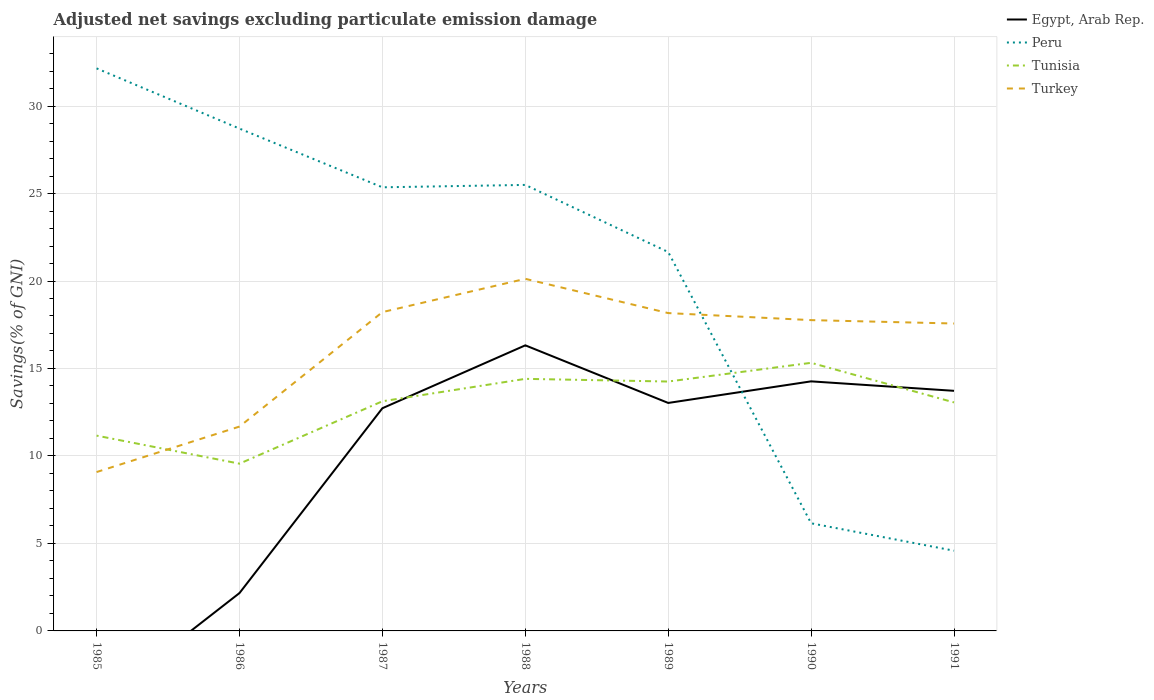Is the number of lines equal to the number of legend labels?
Your response must be concise. No. Across all years, what is the maximum adjusted net savings in Turkey?
Your response must be concise. 9.08. What is the total adjusted net savings in Egypt, Arab Rep. in the graph?
Ensure brevity in your answer.  0.54. What is the difference between the highest and the second highest adjusted net savings in Peru?
Your answer should be very brief. 27.57. What is the difference between two consecutive major ticks on the Y-axis?
Offer a very short reply. 5. Does the graph contain any zero values?
Make the answer very short. Yes. Does the graph contain grids?
Offer a terse response. Yes. How many legend labels are there?
Provide a short and direct response. 4. What is the title of the graph?
Provide a succinct answer. Adjusted net savings excluding particulate emission damage. What is the label or title of the X-axis?
Your response must be concise. Years. What is the label or title of the Y-axis?
Make the answer very short. Savings(% of GNI). What is the Savings(% of GNI) in Egypt, Arab Rep. in 1985?
Give a very brief answer. 0. What is the Savings(% of GNI) in Peru in 1985?
Your answer should be compact. 32.15. What is the Savings(% of GNI) of Tunisia in 1985?
Offer a terse response. 11.16. What is the Savings(% of GNI) of Turkey in 1985?
Offer a terse response. 9.08. What is the Savings(% of GNI) of Egypt, Arab Rep. in 1986?
Offer a terse response. 2.16. What is the Savings(% of GNI) of Peru in 1986?
Your response must be concise. 28.71. What is the Savings(% of GNI) of Tunisia in 1986?
Make the answer very short. 9.56. What is the Savings(% of GNI) of Turkey in 1986?
Keep it short and to the point. 11.68. What is the Savings(% of GNI) of Egypt, Arab Rep. in 1987?
Ensure brevity in your answer.  12.73. What is the Savings(% of GNI) in Peru in 1987?
Keep it short and to the point. 25.36. What is the Savings(% of GNI) of Tunisia in 1987?
Your response must be concise. 13.13. What is the Savings(% of GNI) in Turkey in 1987?
Give a very brief answer. 18.22. What is the Savings(% of GNI) of Egypt, Arab Rep. in 1988?
Ensure brevity in your answer.  16.32. What is the Savings(% of GNI) of Peru in 1988?
Provide a short and direct response. 25.49. What is the Savings(% of GNI) in Tunisia in 1988?
Offer a very short reply. 14.41. What is the Savings(% of GNI) in Turkey in 1988?
Your response must be concise. 20.12. What is the Savings(% of GNI) in Egypt, Arab Rep. in 1989?
Ensure brevity in your answer.  13.03. What is the Savings(% of GNI) in Peru in 1989?
Ensure brevity in your answer.  21.66. What is the Savings(% of GNI) of Tunisia in 1989?
Provide a short and direct response. 14.25. What is the Savings(% of GNI) in Turkey in 1989?
Your answer should be very brief. 18.17. What is the Savings(% of GNI) in Egypt, Arab Rep. in 1990?
Your answer should be compact. 14.26. What is the Savings(% of GNI) of Peru in 1990?
Your answer should be compact. 6.15. What is the Savings(% of GNI) of Tunisia in 1990?
Provide a short and direct response. 15.32. What is the Savings(% of GNI) in Turkey in 1990?
Offer a terse response. 17.76. What is the Savings(% of GNI) in Egypt, Arab Rep. in 1991?
Your response must be concise. 13.72. What is the Savings(% of GNI) of Peru in 1991?
Ensure brevity in your answer.  4.58. What is the Savings(% of GNI) in Tunisia in 1991?
Offer a very short reply. 13.06. What is the Savings(% of GNI) of Turkey in 1991?
Make the answer very short. 17.57. Across all years, what is the maximum Savings(% of GNI) in Egypt, Arab Rep.?
Ensure brevity in your answer.  16.32. Across all years, what is the maximum Savings(% of GNI) in Peru?
Give a very brief answer. 32.15. Across all years, what is the maximum Savings(% of GNI) in Tunisia?
Your answer should be compact. 15.32. Across all years, what is the maximum Savings(% of GNI) of Turkey?
Your response must be concise. 20.12. Across all years, what is the minimum Savings(% of GNI) of Peru?
Your answer should be very brief. 4.58. Across all years, what is the minimum Savings(% of GNI) in Tunisia?
Your answer should be very brief. 9.56. Across all years, what is the minimum Savings(% of GNI) in Turkey?
Your answer should be compact. 9.08. What is the total Savings(% of GNI) of Egypt, Arab Rep. in the graph?
Make the answer very short. 72.23. What is the total Savings(% of GNI) in Peru in the graph?
Give a very brief answer. 144.1. What is the total Savings(% of GNI) of Tunisia in the graph?
Give a very brief answer. 90.89. What is the total Savings(% of GNI) of Turkey in the graph?
Offer a terse response. 112.61. What is the difference between the Savings(% of GNI) of Peru in 1985 and that in 1986?
Offer a terse response. 3.44. What is the difference between the Savings(% of GNI) of Tunisia in 1985 and that in 1986?
Provide a short and direct response. 1.6. What is the difference between the Savings(% of GNI) of Turkey in 1985 and that in 1986?
Provide a short and direct response. -2.6. What is the difference between the Savings(% of GNI) in Peru in 1985 and that in 1987?
Give a very brief answer. 6.8. What is the difference between the Savings(% of GNI) in Tunisia in 1985 and that in 1987?
Your response must be concise. -1.96. What is the difference between the Savings(% of GNI) of Turkey in 1985 and that in 1987?
Your response must be concise. -9.14. What is the difference between the Savings(% of GNI) in Peru in 1985 and that in 1988?
Your answer should be very brief. 6.66. What is the difference between the Savings(% of GNI) of Tunisia in 1985 and that in 1988?
Keep it short and to the point. -3.25. What is the difference between the Savings(% of GNI) of Turkey in 1985 and that in 1988?
Your answer should be compact. -11.04. What is the difference between the Savings(% of GNI) of Peru in 1985 and that in 1989?
Your response must be concise. 10.5. What is the difference between the Savings(% of GNI) in Tunisia in 1985 and that in 1989?
Ensure brevity in your answer.  -3.09. What is the difference between the Savings(% of GNI) of Turkey in 1985 and that in 1989?
Ensure brevity in your answer.  -9.09. What is the difference between the Savings(% of GNI) of Peru in 1985 and that in 1990?
Your answer should be compact. 26. What is the difference between the Savings(% of GNI) of Tunisia in 1985 and that in 1990?
Keep it short and to the point. -4.16. What is the difference between the Savings(% of GNI) of Turkey in 1985 and that in 1990?
Keep it short and to the point. -8.68. What is the difference between the Savings(% of GNI) in Peru in 1985 and that in 1991?
Offer a very short reply. 27.57. What is the difference between the Savings(% of GNI) of Tunisia in 1985 and that in 1991?
Offer a very short reply. -1.9. What is the difference between the Savings(% of GNI) of Turkey in 1985 and that in 1991?
Provide a succinct answer. -8.49. What is the difference between the Savings(% of GNI) in Egypt, Arab Rep. in 1986 and that in 1987?
Give a very brief answer. -10.56. What is the difference between the Savings(% of GNI) in Peru in 1986 and that in 1987?
Make the answer very short. 3.36. What is the difference between the Savings(% of GNI) in Tunisia in 1986 and that in 1987?
Give a very brief answer. -3.57. What is the difference between the Savings(% of GNI) in Turkey in 1986 and that in 1987?
Make the answer very short. -6.54. What is the difference between the Savings(% of GNI) in Egypt, Arab Rep. in 1986 and that in 1988?
Your answer should be compact. -14.16. What is the difference between the Savings(% of GNI) in Peru in 1986 and that in 1988?
Your answer should be compact. 3.22. What is the difference between the Savings(% of GNI) in Tunisia in 1986 and that in 1988?
Your answer should be compact. -4.85. What is the difference between the Savings(% of GNI) in Turkey in 1986 and that in 1988?
Offer a terse response. -8.44. What is the difference between the Savings(% of GNI) in Egypt, Arab Rep. in 1986 and that in 1989?
Give a very brief answer. -10.87. What is the difference between the Savings(% of GNI) of Peru in 1986 and that in 1989?
Offer a very short reply. 7.05. What is the difference between the Savings(% of GNI) of Tunisia in 1986 and that in 1989?
Ensure brevity in your answer.  -4.69. What is the difference between the Savings(% of GNI) in Turkey in 1986 and that in 1989?
Keep it short and to the point. -6.49. What is the difference between the Savings(% of GNI) in Egypt, Arab Rep. in 1986 and that in 1990?
Provide a short and direct response. -12.1. What is the difference between the Savings(% of GNI) of Peru in 1986 and that in 1990?
Your answer should be compact. 22.56. What is the difference between the Savings(% of GNI) in Tunisia in 1986 and that in 1990?
Provide a short and direct response. -5.76. What is the difference between the Savings(% of GNI) in Turkey in 1986 and that in 1990?
Offer a terse response. -6.08. What is the difference between the Savings(% of GNI) in Egypt, Arab Rep. in 1986 and that in 1991?
Your answer should be compact. -11.56. What is the difference between the Savings(% of GNI) in Peru in 1986 and that in 1991?
Provide a short and direct response. 24.13. What is the difference between the Savings(% of GNI) of Tunisia in 1986 and that in 1991?
Offer a very short reply. -3.5. What is the difference between the Savings(% of GNI) in Turkey in 1986 and that in 1991?
Provide a short and direct response. -5.89. What is the difference between the Savings(% of GNI) of Egypt, Arab Rep. in 1987 and that in 1988?
Provide a short and direct response. -3.59. What is the difference between the Savings(% of GNI) of Peru in 1987 and that in 1988?
Offer a very short reply. -0.14. What is the difference between the Savings(% of GNI) of Tunisia in 1987 and that in 1988?
Offer a very short reply. -1.28. What is the difference between the Savings(% of GNI) in Turkey in 1987 and that in 1988?
Make the answer very short. -1.9. What is the difference between the Savings(% of GNI) in Egypt, Arab Rep. in 1987 and that in 1989?
Give a very brief answer. -0.3. What is the difference between the Savings(% of GNI) in Peru in 1987 and that in 1989?
Provide a succinct answer. 3.7. What is the difference between the Savings(% of GNI) of Tunisia in 1987 and that in 1989?
Your response must be concise. -1.13. What is the difference between the Savings(% of GNI) of Turkey in 1987 and that in 1989?
Offer a very short reply. 0.06. What is the difference between the Savings(% of GNI) of Egypt, Arab Rep. in 1987 and that in 1990?
Your answer should be compact. -1.54. What is the difference between the Savings(% of GNI) in Peru in 1987 and that in 1990?
Ensure brevity in your answer.  19.2. What is the difference between the Savings(% of GNI) in Tunisia in 1987 and that in 1990?
Give a very brief answer. -2.2. What is the difference between the Savings(% of GNI) in Turkey in 1987 and that in 1990?
Your answer should be very brief. 0.46. What is the difference between the Savings(% of GNI) of Egypt, Arab Rep. in 1987 and that in 1991?
Make the answer very short. -0.99. What is the difference between the Savings(% of GNI) in Peru in 1987 and that in 1991?
Give a very brief answer. 20.77. What is the difference between the Savings(% of GNI) of Tunisia in 1987 and that in 1991?
Provide a succinct answer. 0.07. What is the difference between the Savings(% of GNI) in Turkey in 1987 and that in 1991?
Keep it short and to the point. 0.65. What is the difference between the Savings(% of GNI) in Egypt, Arab Rep. in 1988 and that in 1989?
Ensure brevity in your answer.  3.29. What is the difference between the Savings(% of GNI) of Peru in 1988 and that in 1989?
Give a very brief answer. 3.84. What is the difference between the Savings(% of GNI) in Tunisia in 1988 and that in 1989?
Keep it short and to the point. 0.15. What is the difference between the Savings(% of GNI) of Turkey in 1988 and that in 1989?
Your answer should be compact. 1.96. What is the difference between the Savings(% of GNI) in Egypt, Arab Rep. in 1988 and that in 1990?
Offer a terse response. 2.06. What is the difference between the Savings(% of GNI) of Peru in 1988 and that in 1990?
Keep it short and to the point. 19.34. What is the difference between the Savings(% of GNI) of Tunisia in 1988 and that in 1990?
Your response must be concise. -0.92. What is the difference between the Savings(% of GNI) of Turkey in 1988 and that in 1990?
Your response must be concise. 2.36. What is the difference between the Savings(% of GNI) in Egypt, Arab Rep. in 1988 and that in 1991?
Offer a terse response. 2.6. What is the difference between the Savings(% of GNI) of Peru in 1988 and that in 1991?
Provide a short and direct response. 20.91. What is the difference between the Savings(% of GNI) in Tunisia in 1988 and that in 1991?
Keep it short and to the point. 1.35. What is the difference between the Savings(% of GNI) in Turkey in 1988 and that in 1991?
Give a very brief answer. 2.55. What is the difference between the Savings(% of GNI) of Egypt, Arab Rep. in 1989 and that in 1990?
Your response must be concise. -1.23. What is the difference between the Savings(% of GNI) in Peru in 1989 and that in 1990?
Give a very brief answer. 15.5. What is the difference between the Savings(% of GNI) in Tunisia in 1989 and that in 1990?
Offer a terse response. -1.07. What is the difference between the Savings(% of GNI) in Turkey in 1989 and that in 1990?
Make the answer very short. 0.4. What is the difference between the Savings(% of GNI) of Egypt, Arab Rep. in 1989 and that in 1991?
Ensure brevity in your answer.  -0.69. What is the difference between the Savings(% of GNI) in Peru in 1989 and that in 1991?
Your response must be concise. 17.07. What is the difference between the Savings(% of GNI) of Tunisia in 1989 and that in 1991?
Your answer should be very brief. 1.19. What is the difference between the Savings(% of GNI) in Turkey in 1989 and that in 1991?
Offer a very short reply. 0.6. What is the difference between the Savings(% of GNI) of Egypt, Arab Rep. in 1990 and that in 1991?
Make the answer very short. 0.54. What is the difference between the Savings(% of GNI) in Peru in 1990 and that in 1991?
Provide a succinct answer. 1.57. What is the difference between the Savings(% of GNI) in Tunisia in 1990 and that in 1991?
Offer a very short reply. 2.26. What is the difference between the Savings(% of GNI) in Turkey in 1990 and that in 1991?
Make the answer very short. 0.19. What is the difference between the Savings(% of GNI) in Peru in 1985 and the Savings(% of GNI) in Tunisia in 1986?
Offer a very short reply. 22.59. What is the difference between the Savings(% of GNI) of Peru in 1985 and the Savings(% of GNI) of Turkey in 1986?
Your answer should be very brief. 20.47. What is the difference between the Savings(% of GNI) in Tunisia in 1985 and the Savings(% of GNI) in Turkey in 1986?
Offer a very short reply. -0.52. What is the difference between the Savings(% of GNI) of Peru in 1985 and the Savings(% of GNI) of Tunisia in 1987?
Offer a very short reply. 19.03. What is the difference between the Savings(% of GNI) of Peru in 1985 and the Savings(% of GNI) of Turkey in 1987?
Your response must be concise. 13.93. What is the difference between the Savings(% of GNI) of Tunisia in 1985 and the Savings(% of GNI) of Turkey in 1987?
Provide a succinct answer. -7.06. What is the difference between the Savings(% of GNI) of Peru in 1985 and the Savings(% of GNI) of Tunisia in 1988?
Ensure brevity in your answer.  17.75. What is the difference between the Savings(% of GNI) of Peru in 1985 and the Savings(% of GNI) of Turkey in 1988?
Offer a terse response. 12.03. What is the difference between the Savings(% of GNI) of Tunisia in 1985 and the Savings(% of GNI) of Turkey in 1988?
Make the answer very short. -8.96. What is the difference between the Savings(% of GNI) of Peru in 1985 and the Savings(% of GNI) of Tunisia in 1989?
Give a very brief answer. 17.9. What is the difference between the Savings(% of GNI) in Peru in 1985 and the Savings(% of GNI) in Turkey in 1989?
Keep it short and to the point. 13.99. What is the difference between the Savings(% of GNI) of Tunisia in 1985 and the Savings(% of GNI) of Turkey in 1989?
Keep it short and to the point. -7. What is the difference between the Savings(% of GNI) of Peru in 1985 and the Savings(% of GNI) of Tunisia in 1990?
Make the answer very short. 16.83. What is the difference between the Savings(% of GNI) of Peru in 1985 and the Savings(% of GNI) of Turkey in 1990?
Keep it short and to the point. 14.39. What is the difference between the Savings(% of GNI) in Tunisia in 1985 and the Savings(% of GNI) in Turkey in 1990?
Give a very brief answer. -6.6. What is the difference between the Savings(% of GNI) in Peru in 1985 and the Savings(% of GNI) in Tunisia in 1991?
Your answer should be compact. 19.09. What is the difference between the Savings(% of GNI) of Peru in 1985 and the Savings(% of GNI) of Turkey in 1991?
Give a very brief answer. 14.58. What is the difference between the Savings(% of GNI) in Tunisia in 1985 and the Savings(% of GNI) in Turkey in 1991?
Ensure brevity in your answer.  -6.41. What is the difference between the Savings(% of GNI) in Egypt, Arab Rep. in 1986 and the Savings(% of GNI) in Peru in 1987?
Your answer should be compact. -23.19. What is the difference between the Savings(% of GNI) of Egypt, Arab Rep. in 1986 and the Savings(% of GNI) of Tunisia in 1987?
Provide a short and direct response. -10.96. What is the difference between the Savings(% of GNI) of Egypt, Arab Rep. in 1986 and the Savings(% of GNI) of Turkey in 1987?
Keep it short and to the point. -16.06. What is the difference between the Savings(% of GNI) in Peru in 1986 and the Savings(% of GNI) in Tunisia in 1987?
Keep it short and to the point. 15.58. What is the difference between the Savings(% of GNI) in Peru in 1986 and the Savings(% of GNI) in Turkey in 1987?
Your answer should be compact. 10.49. What is the difference between the Savings(% of GNI) of Tunisia in 1986 and the Savings(% of GNI) of Turkey in 1987?
Your answer should be very brief. -8.66. What is the difference between the Savings(% of GNI) in Egypt, Arab Rep. in 1986 and the Savings(% of GNI) in Peru in 1988?
Your response must be concise. -23.33. What is the difference between the Savings(% of GNI) in Egypt, Arab Rep. in 1986 and the Savings(% of GNI) in Tunisia in 1988?
Ensure brevity in your answer.  -12.24. What is the difference between the Savings(% of GNI) of Egypt, Arab Rep. in 1986 and the Savings(% of GNI) of Turkey in 1988?
Make the answer very short. -17.96. What is the difference between the Savings(% of GNI) of Peru in 1986 and the Savings(% of GNI) of Tunisia in 1988?
Provide a short and direct response. 14.3. What is the difference between the Savings(% of GNI) in Peru in 1986 and the Savings(% of GNI) in Turkey in 1988?
Give a very brief answer. 8.59. What is the difference between the Savings(% of GNI) in Tunisia in 1986 and the Savings(% of GNI) in Turkey in 1988?
Make the answer very short. -10.56. What is the difference between the Savings(% of GNI) of Egypt, Arab Rep. in 1986 and the Savings(% of GNI) of Peru in 1989?
Provide a succinct answer. -19.49. What is the difference between the Savings(% of GNI) of Egypt, Arab Rep. in 1986 and the Savings(% of GNI) of Tunisia in 1989?
Your response must be concise. -12.09. What is the difference between the Savings(% of GNI) of Egypt, Arab Rep. in 1986 and the Savings(% of GNI) of Turkey in 1989?
Your answer should be compact. -16. What is the difference between the Savings(% of GNI) in Peru in 1986 and the Savings(% of GNI) in Tunisia in 1989?
Provide a succinct answer. 14.46. What is the difference between the Savings(% of GNI) of Peru in 1986 and the Savings(% of GNI) of Turkey in 1989?
Your answer should be compact. 10.54. What is the difference between the Savings(% of GNI) in Tunisia in 1986 and the Savings(% of GNI) in Turkey in 1989?
Offer a very short reply. -8.61. What is the difference between the Savings(% of GNI) in Egypt, Arab Rep. in 1986 and the Savings(% of GNI) in Peru in 1990?
Your response must be concise. -3.99. What is the difference between the Savings(% of GNI) in Egypt, Arab Rep. in 1986 and the Savings(% of GNI) in Tunisia in 1990?
Provide a succinct answer. -13.16. What is the difference between the Savings(% of GNI) of Egypt, Arab Rep. in 1986 and the Savings(% of GNI) of Turkey in 1990?
Offer a very short reply. -15.6. What is the difference between the Savings(% of GNI) of Peru in 1986 and the Savings(% of GNI) of Tunisia in 1990?
Provide a succinct answer. 13.39. What is the difference between the Savings(% of GNI) in Peru in 1986 and the Savings(% of GNI) in Turkey in 1990?
Your response must be concise. 10.95. What is the difference between the Savings(% of GNI) in Tunisia in 1986 and the Savings(% of GNI) in Turkey in 1990?
Offer a very short reply. -8.2. What is the difference between the Savings(% of GNI) in Egypt, Arab Rep. in 1986 and the Savings(% of GNI) in Peru in 1991?
Your answer should be very brief. -2.42. What is the difference between the Savings(% of GNI) in Egypt, Arab Rep. in 1986 and the Savings(% of GNI) in Tunisia in 1991?
Your response must be concise. -10.9. What is the difference between the Savings(% of GNI) of Egypt, Arab Rep. in 1986 and the Savings(% of GNI) of Turkey in 1991?
Provide a short and direct response. -15.41. What is the difference between the Savings(% of GNI) of Peru in 1986 and the Savings(% of GNI) of Tunisia in 1991?
Give a very brief answer. 15.65. What is the difference between the Savings(% of GNI) of Peru in 1986 and the Savings(% of GNI) of Turkey in 1991?
Give a very brief answer. 11.14. What is the difference between the Savings(% of GNI) in Tunisia in 1986 and the Savings(% of GNI) in Turkey in 1991?
Ensure brevity in your answer.  -8.01. What is the difference between the Savings(% of GNI) in Egypt, Arab Rep. in 1987 and the Savings(% of GNI) in Peru in 1988?
Your response must be concise. -12.76. What is the difference between the Savings(% of GNI) of Egypt, Arab Rep. in 1987 and the Savings(% of GNI) of Tunisia in 1988?
Your answer should be very brief. -1.68. What is the difference between the Savings(% of GNI) of Egypt, Arab Rep. in 1987 and the Savings(% of GNI) of Turkey in 1988?
Offer a terse response. -7.4. What is the difference between the Savings(% of GNI) in Peru in 1987 and the Savings(% of GNI) in Tunisia in 1988?
Provide a short and direct response. 10.95. What is the difference between the Savings(% of GNI) in Peru in 1987 and the Savings(% of GNI) in Turkey in 1988?
Your response must be concise. 5.23. What is the difference between the Savings(% of GNI) of Tunisia in 1987 and the Savings(% of GNI) of Turkey in 1988?
Offer a very short reply. -7. What is the difference between the Savings(% of GNI) of Egypt, Arab Rep. in 1987 and the Savings(% of GNI) of Peru in 1989?
Your answer should be very brief. -8.93. What is the difference between the Savings(% of GNI) of Egypt, Arab Rep. in 1987 and the Savings(% of GNI) of Tunisia in 1989?
Make the answer very short. -1.53. What is the difference between the Savings(% of GNI) in Egypt, Arab Rep. in 1987 and the Savings(% of GNI) in Turkey in 1989?
Make the answer very short. -5.44. What is the difference between the Savings(% of GNI) of Peru in 1987 and the Savings(% of GNI) of Tunisia in 1989?
Provide a succinct answer. 11.1. What is the difference between the Savings(% of GNI) in Peru in 1987 and the Savings(% of GNI) in Turkey in 1989?
Your answer should be very brief. 7.19. What is the difference between the Savings(% of GNI) of Tunisia in 1987 and the Savings(% of GNI) of Turkey in 1989?
Offer a terse response. -5.04. What is the difference between the Savings(% of GNI) in Egypt, Arab Rep. in 1987 and the Savings(% of GNI) in Peru in 1990?
Your answer should be compact. 6.58. What is the difference between the Savings(% of GNI) in Egypt, Arab Rep. in 1987 and the Savings(% of GNI) in Tunisia in 1990?
Offer a terse response. -2.6. What is the difference between the Savings(% of GNI) in Egypt, Arab Rep. in 1987 and the Savings(% of GNI) in Turkey in 1990?
Keep it short and to the point. -5.04. What is the difference between the Savings(% of GNI) in Peru in 1987 and the Savings(% of GNI) in Tunisia in 1990?
Keep it short and to the point. 10.03. What is the difference between the Savings(% of GNI) in Peru in 1987 and the Savings(% of GNI) in Turkey in 1990?
Provide a succinct answer. 7.59. What is the difference between the Savings(% of GNI) in Tunisia in 1987 and the Savings(% of GNI) in Turkey in 1990?
Provide a short and direct response. -4.64. What is the difference between the Savings(% of GNI) in Egypt, Arab Rep. in 1987 and the Savings(% of GNI) in Peru in 1991?
Your answer should be compact. 8.14. What is the difference between the Savings(% of GNI) in Egypt, Arab Rep. in 1987 and the Savings(% of GNI) in Tunisia in 1991?
Provide a short and direct response. -0.33. What is the difference between the Savings(% of GNI) of Egypt, Arab Rep. in 1987 and the Savings(% of GNI) of Turkey in 1991?
Your response must be concise. -4.84. What is the difference between the Savings(% of GNI) of Peru in 1987 and the Savings(% of GNI) of Tunisia in 1991?
Give a very brief answer. 12.29. What is the difference between the Savings(% of GNI) of Peru in 1987 and the Savings(% of GNI) of Turkey in 1991?
Your response must be concise. 7.79. What is the difference between the Savings(% of GNI) of Tunisia in 1987 and the Savings(% of GNI) of Turkey in 1991?
Your answer should be very brief. -4.44. What is the difference between the Savings(% of GNI) of Egypt, Arab Rep. in 1988 and the Savings(% of GNI) of Peru in 1989?
Offer a very short reply. -5.33. What is the difference between the Savings(% of GNI) of Egypt, Arab Rep. in 1988 and the Savings(% of GNI) of Tunisia in 1989?
Offer a very short reply. 2.07. What is the difference between the Savings(% of GNI) in Egypt, Arab Rep. in 1988 and the Savings(% of GNI) in Turkey in 1989?
Make the answer very short. -1.84. What is the difference between the Savings(% of GNI) of Peru in 1988 and the Savings(% of GNI) of Tunisia in 1989?
Provide a succinct answer. 11.24. What is the difference between the Savings(% of GNI) of Peru in 1988 and the Savings(% of GNI) of Turkey in 1989?
Give a very brief answer. 7.33. What is the difference between the Savings(% of GNI) in Tunisia in 1988 and the Savings(% of GNI) in Turkey in 1989?
Provide a short and direct response. -3.76. What is the difference between the Savings(% of GNI) in Egypt, Arab Rep. in 1988 and the Savings(% of GNI) in Peru in 1990?
Give a very brief answer. 10.17. What is the difference between the Savings(% of GNI) of Egypt, Arab Rep. in 1988 and the Savings(% of GNI) of Turkey in 1990?
Give a very brief answer. -1.44. What is the difference between the Savings(% of GNI) of Peru in 1988 and the Savings(% of GNI) of Tunisia in 1990?
Provide a short and direct response. 10.17. What is the difference between the Savings(% of GNI) of Peru in 1988 and the Savings(% of GNI) of Turkey in 1990?
Your answer should be compact. 7.73. What is the difference between the Savings(% of GNI) of Tunisia in 1988 and the Savings(% of GNI) of Turkey in 1990?
Offer a terse response. -3.36. What is the difference between the Savings(% of GNI) in Egypt, Arab Rep. in 1988 and the Savings(% of GNI) in Peru in 1991?
Give a very brief answer. 11.74. What is the difference between the Savings(% of GNI) of Egypt, Arab Rep. in 1988 and the Savings(% of GNI) of Tunisia in 1991?
Provide a succinct answer. 3.26. What is the difference between the Savings(% of GNI) in Egypt, Arab Rep. in 1988 and the Savings(% of GNI) in Turkey in 1991?
Give a very brief answer. -1.25. What is the difference between the Savings(% of GNI) of Peru in 1988 and the Savings(% of GNI) of Tunisia in 1991?
Your response must be concise. 12.43. What is the difference between the Savings(% of GNI) in Peru in 1988 and the Savings(% of GNI) in Turkey in 1991?
Your answer should be very brief. 7.92. What is the difference between the Savings(% of GNI) in Tunisia in 1988 and the Savings(% of GNI) in Turkey in 1991?
Offer a very short reply. -3.16. What is the difference between the Savings(% of GNI) of Egypt, Arab Rep. in 1989 and the Savings(% of GNI) of Peru in 1990?
Your answer should be compact. 6.88. What is the difference between the Savings(% of GNI) in Egypt, Arab Rep. in 1989 and the Savings(% of GNI) in Tunisia in 1990?
Your response must be concise. -2.29. What is the difference between the Savings(% of GNI) of Egypt, Arab Rep. in 1989 and the Savings(% of GNI) of Turkey in 1990?
Ensure brevity in your answer.  -4.73. What is the difference between the Savings(% of GNI) of Peru in 1989 and the Savings(% of GNI) of Tunisia in 1990?
Ensure brevity in your answer.  6.33. What is the difference between the Savings(% of GNI) in Peru in 1989 and the Savings(% of GNI) in Turkey in 1990?
Give a very brief answer. 3.89. What is the difference between the Savings(% of GNI) in Tunisia in 1989 and the Savings(% of GNI) in Turkey in 1990?
Offer a very short reply. -3.51. What is the difference between the Savings(% of GNI) in Egypt, Arab Rep. in 1989 and the Savings(% of GNI) in Peru in 1991?
Provide a succinct answer. 8.45. What is the difference between the Savings(% of GNI) in Egypt, Arab Rep. in 1989 and the Savings(% of GNI) in Tunisia in 1991?
Offer a very short reply. -0.03. What is the difference between the Savings(% of GNI) in Egypt, Arab Rep. in 1989 and the Savings(% of GNI) in Turkey in 1991?
Keep it short and to the point. -4.54. What is the difference between the Savings(% of GNI) of Peru in 1989 and the Savings(% of GNI) of Tunisia in 1991?
Your response must be concise. 8.59. What is the difference between the Savings(% of GNI) in Peru in 1989 and the Savings(% of GNI) in Turkey in 1991?
Make the answer very short. 4.09. What is the difference between the Savings(% of GNI) in Tunisia in 1989 and the Savings(% of GNI) in Turkey in 1991?
Offer a terse response. -3.32. What is the difference between the Savings(% of GNI) in Egypt, Arab Rep. in 1990 and the Savings(% of GNI) in Peru in 1991?
Provide a succinct answer. 9.68. What is the difference between the Savings(% of GNI) in Egypt, Arab Rep. in 1990 and the Savings(% of GNI) in Tunisia in 1991?
Your answer should be compact. 1.2. What is the difference between the Savings(% of GNI) in Egypt, Arab Rep. in 1990 and the Savings(% of GNI) in Turkey in 1991?
Offer a terse response. -3.31. What is the difference between the Savings(% of GNI) in Peru in 1990 and the Savings(% of GNI) in Tunisia in 1991?
Your answer should be compact. -6.91. What is the difference between the Savings(% of GNI) of Peru in 1990 and the Savings(% of GNI) of Turkey in 1991?
Your response must be concise. -11.42. What is the difference between the Savings(% of GNI) in Tunisia in 1990 and the Savings(% of GNI) in Turkey in 1991?
Your response must be concise. -2.25. What is the average Savings(% of GNI) of Egypt, Arab Rep. per year?
Your response must be concise. 10.32. What is the average Savings(% of GNI) in Peru per year?
Provide a succinct answer. 20.59. What is the average Savings(% of GNI) in Tunisia per year?
Your answer should be compact. 12.98. What is the average Savings(% of GNI) in Turkey per year?
Your response must be concise. 16.09. In the year 1985, what is the difference between the Savings(% of GNI) of Peru and Savings(% of GNI) of Tunisia?
Your response must be concise. 20.99. In the year 1985, what is the difference between the Savings(% of GNI) of Peru and Savings(% of GNI) of Turkey?
Your answer should be compact. 23.07. In the year 1985, what is the difference between the Savings(% of GNI) of Tunisia and Savings(% of GNI) of Turkey?
Provide a short and direct response. 2.08. In the year 1986, what is the difference between the Savings(% of GNI) of Egypt, Arab Rep. and Savings(% of GNI) of Peru?
Make the answer very short. -26.55. In the year 1986, what is the difference between the Savings(% of GNI) of Egypt, Arab Rep. and Savings(% of GNI) of Tunisia?
Ensure brevity in your answer.  -7.4. In the year 1986, what is the difference between the Savings(% of GNI) of Egypt, Arab Rep. and Savings(% of GNI) of Turkey?
Your answer should be compact. -9.52. In the year 1986, what is the difference between the Savings(% of GNI) of Peru and Savings(% of GNI) of Tunisia?
Make the answer very short. 19.15. In the year 1986, what is the difference between the Savings(% of GNI) of Peru and Savings(% of GNI) of Turkey?
Your answer should be compact. 17.03. In the year 1986, what is the difference between the Savings(% of GNI) of Tunisia and Savings(% of GNI) of Turkey?
Offer a terse response. -2.12. In the year 1987, what is the difference between the Savings(% of GNI) in Egypt, Arab Rep. and Savings(% of GNI) in Peru?
Offer a very short reply. -12.63. In the year 1987, what is the difference between the Savings(% of GNI) in Egypt, Arab Rep. and Savings(% of GNI) in Tunisia?
Offer a very short reply. -0.4. In the year 1987, what is the difference between the Savings(% of GNI) in Egypt, Arab Rep. and Savings(% of GNI) in Turkey?
Provide a short and direct response. -5.49. In the year 1987, what is the difference between the Savings(% of GNI) in Peru and Savings(% of GNI) in Tunisia?
Your response must be concise. 12.23. In the year 1987, what is the difference between the Savings(% of GNI) in Peru and Savings(% of GNI) in Turkey?
Offer a very short reply. 7.13. In the year 1987, what is the difference between the Savings(% of GNI) of Tunisia and Savings(% of GNI) of Turkey?
Offer a very short reply. -5.1. In the year 1988, what is the difference between the Savings(% of GNI) of Egypt, Arab Rep. and Savings(% of GNI) of Peru?
Your answer should be compact. -9.17. In the year 1988, what is the difference between the Savings(% of GNI) in Egypt, Arab Rep. and Savings(% of GNI) in Tunisia?
Your answer should be very brief. 1.92. In the year 1988, what is the difference between the Savings(% of GNI) of Egypt, Arab Rep. and Savings(% of GNI) of Turkey?
Give a very brief answer. -3.8. In the year 1988, what is the difference between the Savings(% of GNI) in Peru and Savings(% of GNI) in Tunisia?
Keep it short and to the point. 11.08. In the year 1988, what is the difference between the Savings(% of GNI) in Peru and Savings(% of GNI) in Turkey?
Your response must be concise. 5.37. In the year 1988, what is the difference between the Savings(% of GNI) of Tunisia and Savings(% of GNI) of Turkey?
Your answer should be very brief. -5.72. In the year 1989, what is the difference between the Savings(% of GNI) of Egypt, Arab Rep. and Savings(% of GNI) of Peru?
Your response must be concise. -8.63. In the year 1989, what is the difference between the Savings(% of GNI) in Egypt, Arab Rep. and Savings(% of GNI) in Tunisia?
Ensure brevity in your answer.  -1.22. In the year 1989, what is the difference between the Savings(% of GNI) in Egypt, Arab Rep. and Savings(% of GNI) in Turkey?
Offer a very short reply. -5.14. In the year 1989, what is the difference between the Savings(% of GNI) of Peru and Savings(% of GNI) of Tunisia?
Keep it short and to the point. 7.4. In the year 1989, what is the difference between the Savings(% of GNI) of Peru and Savings(% of GNI) of Turkey?
Provide a succinct answer. 3.49. In the year 1989, what is the difference between the Savings(% of GNI) of Tunisia and Savings(% of GNI) of Turkey?
Ensure brevity in your answer.  -3.91. In the year 1990, what is the difference between the Savings(% of GNI) of Egypt, Arab Rep. and Savings(% of GNI) of Peru?
Keep it short and to the point. 8.11. In the year 1990, what is the difference between the Savings(% of GNI) in Egypt, Arab Rep. and Savings(% of GNI) in Tunisia?
Ensure brevity in your answer.  -1.06. In the year 1990, what is the difference between the Savings(% of GNI) of Egypt, Arab Rep. and Savings(% of GNI) of Turkey?
Your answer should be very brief. -3.5. In the year 1990, what is the difference between the Savings(% of GNI) in Peru and Savings(% of GNI) in Tunisia?
Keep it short and to the point. -9.17. In the year 1990, what is the difference between the Savings(% of GNI) of Peru and Savings(% of GNI) of Turkey?
Provide a short and direct response. -11.61. In the year 1990, what is the difference between the Savings(% of GNI) in Tunisia and Savings(% of GNI) in Turkey?
Make the answer very short. -2.44. In the year 1991, what is the difference between the Savings(% of GNI) in Egypt, Arab Rep. and Savings(% of GNI) in Peru?
Ensure brevity in your answer.  9.14. In the year 1991, what is the difference between the Savings(% of GNI) of Egypt, Arab Rep. and Savings(% of GNI) of Tunisia?
Keep it short and to the point. 0.66. In the year 1991, what is the difference between the Savings(% of GNI) in Egypt, Arab Rep. and Savings(% of GNI) in Turkey?
Make the answer very short. -3.85. In the year 1991, what is the difference between the Savings(% of GNI) of Peru and Savings(% of GNI) of Tunisia?
Provide a short and direct response. -8.48. In the year 1991, what is the difference between the Savings(% of GNI) in Peru and Savings(% of GNI) in Turkey?
Provide a short and direct response. -12.99. In the year 1991, what is the difference between the Savings(% of GNI) in Tunisia and Savings(% of GNI) in Turkey?
Ensure brevity in your answer.  -4.51. What is the ratio of the Savings(% of GNI) of Peru in 1985 to that in 1986?
Offer a terse response. 1.12. What is the ratio of the Savings(% of GNI) of Tunisia in 1985 to that in 1986?
Keep it short and to the point. 1.17. What is the ratio of the Savings(% of GNI) of Turkey in 1985 to that in 1986?
Offer a very short reply. 0.78. What is the ratio of the Savings(% of GNI) in Peru in 1985 to that in 1987?
Give a very brief answer. 1.27. What is the ratio of the Savings(% of GNI) of Tunisia in 1985 to that in 1987?
Offer a very short reply. 0.85. What is the ratio of the Savings(% of GNI) in Turkey in 1985 to that in 1987?
Your answer should be very brief. 0.5. What is the ratio of the Savings(% of GNI) of Peru in 1985 to that in 1988?
Offer a terse response. 1.26. What is the ratio of the Savings(% of GNI) of Tunisia in 1985 to that in 1988?
Provide a succinct answer. 0.77. What is the ratio of the Savings(% of GNI) of Turkey in 1985 to that in 1988?
Keep it short and to the point. 0.45. What is the ratio of the Savings(% of GNI) in Peru in 1985 to that in 1989?
Provide a short and direct response. 1.48. What is the ratio of the Savings(% of GNI) in Tunisia in 1985 to that in 1989?
Keep it short and to the point. 0.78. What is the ratio of the Savings(% of GNI) in Turkey in 1985 to that in 1989?
Your answer should be very brief. 0.5. What is the ratio of the Savings(% of GNI) in Peru in 1985 to that in 1990?
Provide a succinct answer. 5.23. What is the ratio of the Savings(% of GNI) in Tunisia in 1985 to that in 1990?
Offer a terse response. 0.73. What is the ratio of the Savings(% of GNI) in Turkey in 1985 to that in 1990?
Provide a short and direct response. 0.51. What is the ratio of the Savings(% of GNI) of Peru in 1985 to that in 1991?
Give a very brief answer. 7.01. What is the ratio of the Savings(% of GNI) of Tunisia in 1985 to that in 1991?
Your response must be concise. 0.85. What is the ratio of the Savings(% of GNI) in Turkey in 1985 to that in 1991?
Make the answer very short. 0.52. What is the ratio of the Savings(% of GNI) of Egypt, Arab Rep. in 1986 to that in 1987?
Provide a short and direct response. 0.17. What is the ratio of the Savings(% of GNI) in Peru in 1986 to that in 1987?
Your answer should be very brief. 1.13. What is the ratio of the Savings(% of GNI) of Tunisia in 1986 to that in 1987?
Your answer should be very brief. 0.73. What is the ratio of the Savings(% of GNI) of Turkey in 1986 to that in 1987?
Your answer should be compact. 0.64. What is the ratio of the Savings(% of GNI) of Egypt, Arab Rep. in 1986 to that in 1988?
Offer a terse response. 0.13. What is the ratio of the Savings(% of GNI) of Peru in 1986 to that in 1988?
Your answer should be very brief. 1.13. What is the ratio of the Savings(% of GNI) of Tunisia in 1986 to that in 1988?
Your response must be concise. 0.66. What is the ratio of the Savings(% of GNI) of Turkey in 1986 to that in 1988?
Provide a succinct answer. 0.58. What is the ratio of the Savings(% of GNI) in Egypt, Arab Rep. in 1986 to that in 1989?
Offer a very short reply. 0.17. What is the ratio of the Savings(% of GNI) of Peru in 1986 to that in 1989?
Give a very brief answer. 1.33. What is the ratio of the Savings(% of GNI) of Tunisia in 1986 to that in 1989?
Your response must be concise. 0.67. What is the ratio of the Savings(% of GNI) in Turkey in 1986 to that in 1989?
Provide a succinct answer. 0.64. What is the ratio of the Savings(% of GNI) of Egypt, Arab Rep. in 1986 to that in 1990?
Offer a terse response. 0.15. What is the ratio of the Savings(% of GNI) in Peru in 1986 to that in 1990?
Ensure brevity in your answer.  4.67. What is the ratio of the Savings(% of GNI) of Tunisia in 1986 to that in 1990?
Give a very brief answer. 0.62. What is the ratio of the Savings(% of GNI) of Turkey in 1986 to that in 1990?
Offer a very short reply. 0.66. What is the ratio of the Savings(% of GNI) of Egypt, Arab Rep. in 1986 to that in 1991?
Your response must be concise. 0.16. What is the ratio of the Savings(% of GNI) of Peru in 1986 to that in 1991?
Provide a short and direct response. 6.26. What is the ratio of the Savings(% of GNI) in Tunisia in 1986 to that in 1991?
Give a very brief answer. 0.73. What is the ratio of the Savings(% of GNI) in Turkey in 1986 to that in 1991?
Your answer should be compact. 0.66. What is the ratio of the Savings(% of GNI) of Egypt, Arab Rep. in 1987 to that in 1988?
Offer a terse response. 0.78. What is the ratio of the Savings(% of GNI) in Peru in 1987 to that in 1988?
Your answer should be compact. 0.99. What is the ratio of the Savings(% of GNI) in Tunisia in 1987 to that in 1988?
Offer a very short reply. 0.91. What is the ratio of the Savings(% of GNI) of Turkey in 1987 to that in 1988?
Your response must be concise. 0.91. What is the ratio of the Savings(% of GNI) of Egypt, Arab Rep. in 1987 to that in 1989?
Give a very brief answer. 0.98. What is the ratio of the Savings(% of GNI) in Peru in 1987 to that in 1989?
Provide a short and direct response. 1.17. What is the ratio of the Savings(% of GNI) of Tunisia in 1987 to that in 1989?
Provide a short and direct response. 0.92. What is the ratio of the Savings(% of GNI) in Egypt, Arab Rep. in 1987 to that in 1990?
Provide a succinct answer. 0.89. What is the ratio of the Savings(% of GNI) in Peru in 1987 to that in 1990?
Offer a terse response. 4.12. What is the ratio of the Savings(% of GNI) in Tunisia in 1987 to that in 1990?
Offer a terse response. 0.86. What is the ratio of the Savings(% of GNI) of Turkey in 1987 to that in 1990?
Keep it short and to the point. 1.03. What is the ratio of the Savings(% of GNI) in Egypt, Arab Rep. in 1987 to that in 1991?
Keep it short and to the point. 0.93. What is the ratio of the Savings(% of GNI) of Peru in 1987 to that in 1991?
Provide a succinct answer. 5.53. What is the ratio of the Savings(% of GNI) of Turkey in 1987 to that in 1991?
Offer a very short reply. 1.04. What is the ratio of the Savings(% of GNI) in Egypt, Arab Rep. in 1988 to that in 1989?
Your response must be concise. 1.25. What is the ratio of the Savings(% of GNI) of Peru in 1988 to that in 1989?
Keep it short and to the point. 1.18. What is the ratio of the Savings(% of GNI) in Tunisia in 1988 to that in 1989?
Offer a very short reply. 1.01. What is the ratio of the Savings(% of GNI) of Turkey in 1988 to that in 1989?
Your answer should be compact. 1.11. What is the ratio of the Savings(% of GNI) in Egypt, Arab Rep. in 1988 to that in 1990?
Provide a succinct answer. 1.14. What is the ratio of the Savings(% of GNI) of Peru in 1988 to that in 1990?
Offer a very short reply. 4.14. What is the ratio of the Savings(% of GNI) of Tunisia in 1988 to that in 1990?
Make the answer very short. 0.94. What is the ratio of the Savings(% of GNI) of Turkey in 1988 to that in 1990?
Give a very brief answer. 1.13. What is the ratio of the Savings(% of GNI) of Egypt, Arab Rep. in 1988 to that in 1991?
Ensure brevity in your answer.  1.19. What is the ratio of the Savings(% of GNI) in Peru in 1988 to that in 1991?
Make the answer very short. 5.56. What is the ratio of the Savings(% of GNI) of Tunisia in 1988 to that in 1991?
Provide a succinct answer. 1.1. What is the ratio of the Savings(% of GNI) in Turkey in 1988 to that in 1991?
Offer a very short reply. 1.15. What is the ratio of the Savings(% of GNI) of Egypt, Arab Rep. in 1989 to that in 1990?
Provide a short and direct response. 0.91. What is the ratio of the Savings(% of GNI) in Peru in 1989 to that in 1990?
Give a very brief answer. 3.52. What is the ratio of the Savings(% of GNI) of Tunisia in 1989 to that in 1990?
Your answer should be compact. 0.93. What is the ratio of the Savings(% of GNI) in Turkey in 1989 to that in 1990?
Ensure brevity in your answer.  1.02. What is the ratio of the Savings(% of GNI) in Egypt, Arab Rep. in 1989 to that in 1991?
Ensure brevity in your answer.  0.95. What is the ratio of the Savings(% of GNI) in Peru in 1989 to that in 1991?
Your answer should be very brief. 4.72. What is the ratio of the Savings(% of GNI) in Tunisia in 1989 to that in 1991?
Your response must be concise. 1.09. What is the ratio of the Savings(% of GNI) of Turkey in 1989 to that in 1991?
Offer a terse response. 1.03. What is the ratio of the Savings(% of GNI) in Egypt, Arab Rep. in 1990 to that in 1991?
Your answer should be very brief. 1.04. What is the ratio of the Savings(% of GNI) in Peru in 1990 to that in 1991?
Offer a terse response. 1.34. What is the ratio of the Savings(% of GNI) in Tunisia in 1990 to that in 1991?
Your response must be concise. 1.17. What is the difference between the highest and the second highest Savings(% of GNI) of Egypt, Arab Rep.?
Provide a succinct answer. 2.06. What is the difference between the highest and the second highest Savings(% of GNI) of Peru?
Ensure brevity in your answer.  3.44. What is the difference between the highest and the second highest Savings(% of GNI) of Tunisia?
Make the answer very short. 0.92. What is the difference between the highest and the second highest Savings(% of GNI) in Turkey?
Provide a succinct answer. 1.9. What is the difference between the highest and the lowest Savings(% of GNI) of Egypt, Arab Rep.?
Offer a terse response. 16.32. What is the difference between the highest and the lowest Savings(% of GNI) in Peru?
Offer a very short reply. 27.57. What is the difference between the highest and the lowest Savings(% of GNI) of Tunisia?
Offer a very short reply. 5.76. What is the difference between the highest and the lowest Savings(% of GNI) in Turkey?
Your response must be concise. 11.04. 